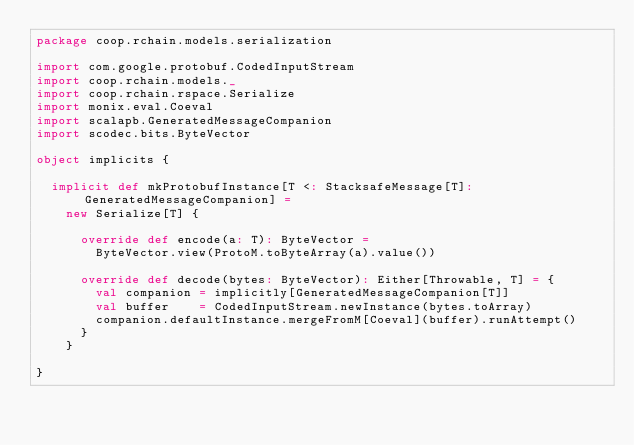<code> <loc_0><loc_0><loc_500><loc_500><_Scala_>package coop.rchain.models.serialization

import com.google.protobuf.CodedInputStream
import coop.rchain.models._
import coop.rchain.rspace.Serialize
import monix.eval.Coeval
import scalapb.GeneratedMessageCompanion
import scodec.bits.ByteVector

object implicits {

  implicit def mkProtobufInstance[T <: StacksafeMessage[T]: GeneratedMessageCompanion] =
    new Serialize[T] {

      override def encode(a: T): ByteVector =
        ByteVector.view(ProtoM.toByteArray(a).value())

      override def decode(bytes: ByteVector): Either[Throwable, T] = {
        val companion = implicitly[GeneratedMessageCompanion[T]]
        val buffer    = CodedInputStream.newInstance(bytes.toArray)
        companion.defaultInstance.mergeFromM[Coeval](buffer).runAttempt()
      }
    }

}
</code> 